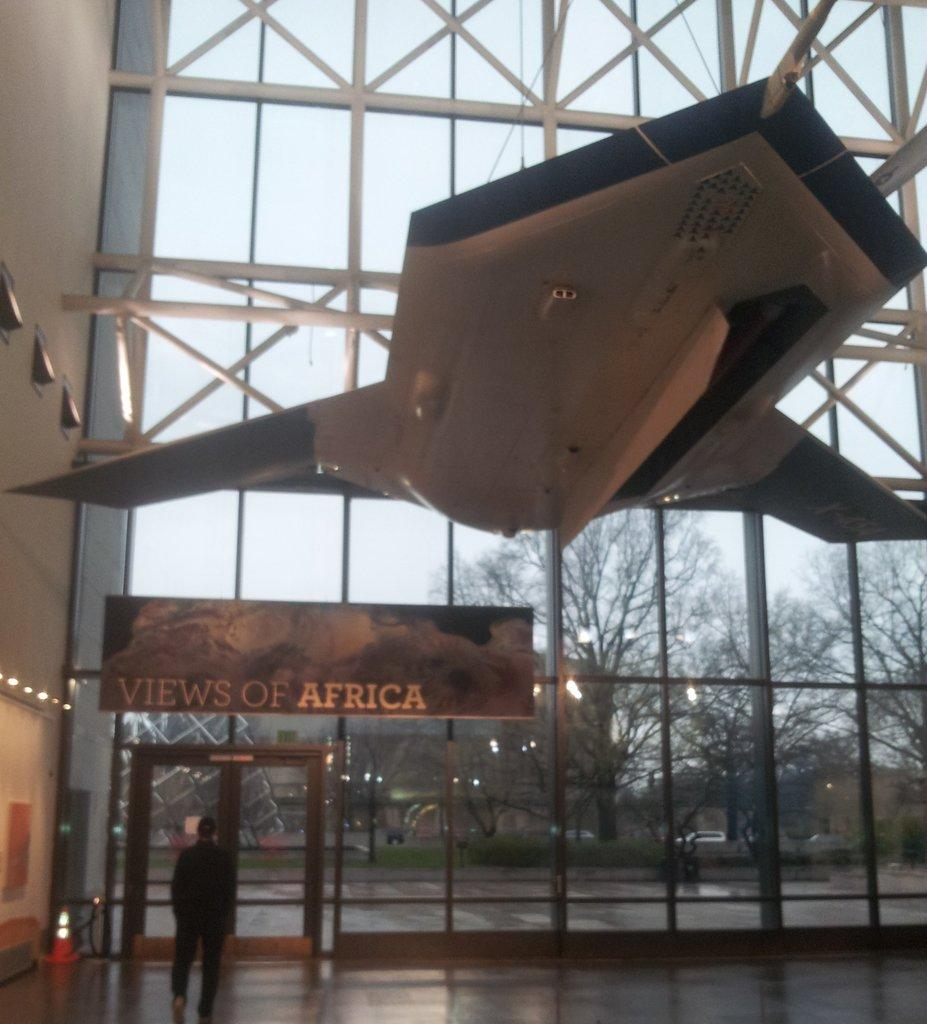<image>
Summarize the visual content of the image. A big glass wall with a banner of views to Africa on it. 